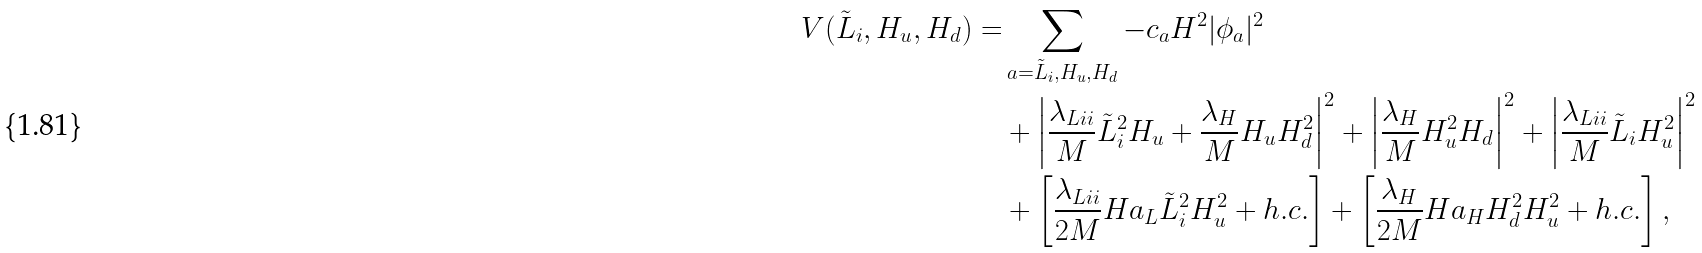Convert formula to latex. <formula><loc_0><loc_0><loc_500><loc_500>V ( { \tilde { L } } _ { i } , H _ { u } , H _ { d } ) = & \sum _ { a = { \tilde { L } } _ { i } , H _ { u } , H _ { d } } - c _ { a } H ^ { 2 } | \phi _ { a } | ^ { 2 } \\ & + \left | \frac { \lambda _ { L i i } } { M } { \tilde { L } } _ { i } ^ { 2 } H _ { u } + \frac { \lambda _ { H } } { M } H _ { u } H _ { d } ^ { 2 } \right | ^ { 2 } + \left | \frac { \lambda _ { H } } { M } H _ { u } ^ { 2 } H _ { d } \right | ^ { 2 } + \left | \frac { \lambda _ { L i i } } { M } { \tilde { L } } _ { i } H _ { u } ^ { 2 } \right | ^ { 2 } \\ & + \left [ \frac { \lambda _ { L i i } } { 2 M } H a _ { L } { \tilde { L } } _ { i } ^ { 2 } H _ { u } ^ { 2 } + h . c . \right ] + \left [ \frac { \lambda _ { H } } { 2 M } H a _ { H } H _ { d } ^ { 2 } H _ { u } ^ { 2 } + h . c . \right ] ,</formula> 